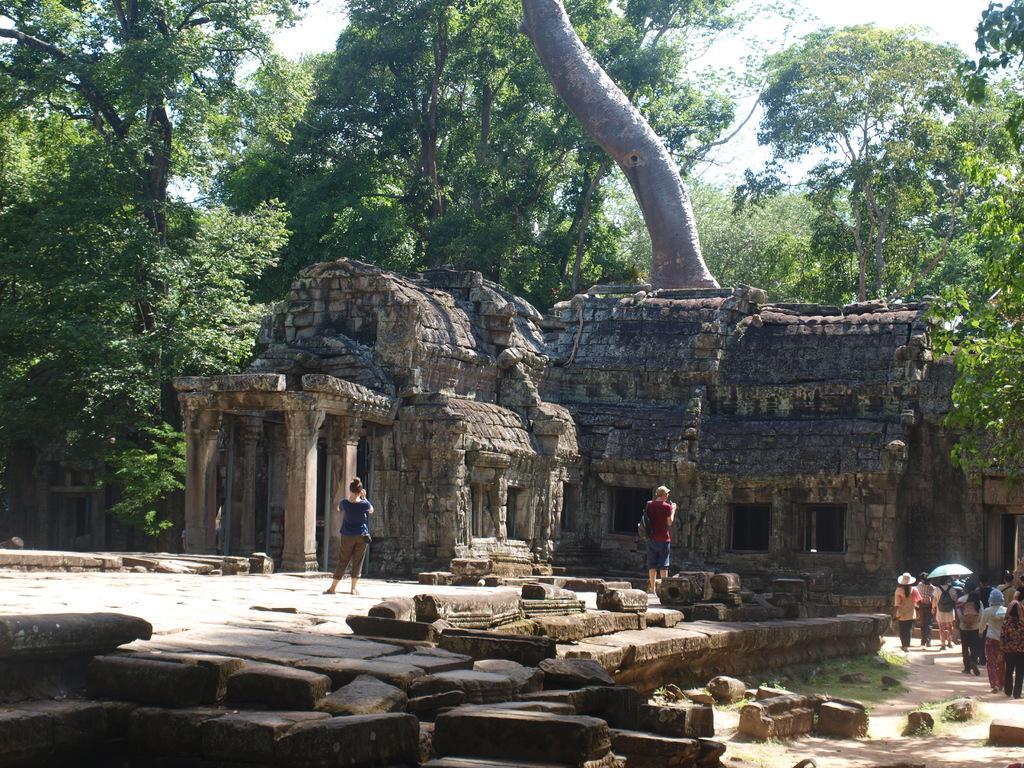Could you give a brief overview of what you see in this image? In this picture we can describe about the old archaeological temple. In the front there is a woman wearing blue t-shirt and shots taking a photographs of the temple. Beside we can see a boy who is watching the temple. Behind we can see many trees and in the front bottom side some stones on the ground. 